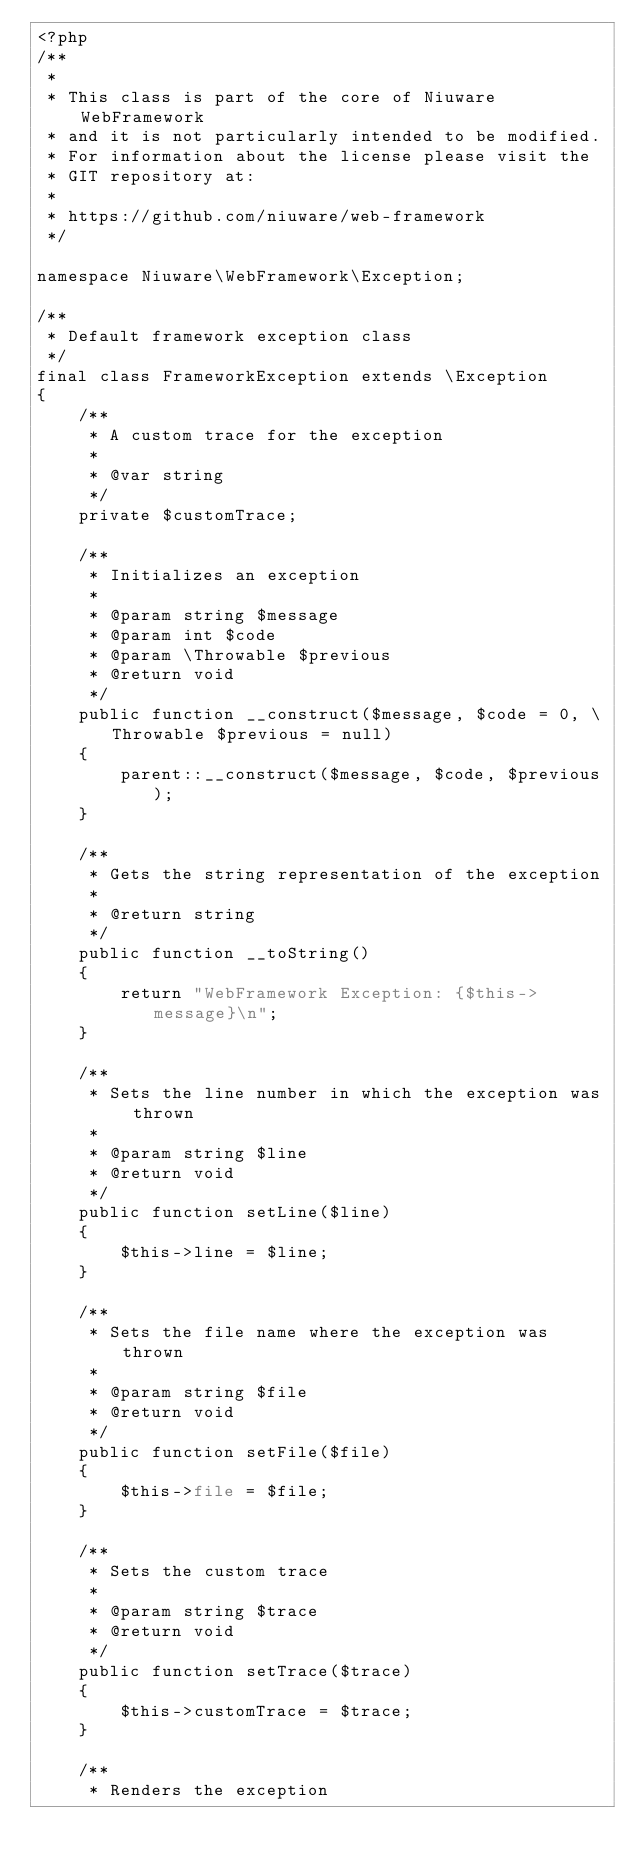<code> <loc_0><loc_0><loc_500><loc_500><_PHP_><?php 
/**
 * 
 * This class is part of the core of Niuware WebFramework 
 * and it is not particularly intended to be modified.
 * For information about the license please visit the 
 * GIT repository at:
 * 
 * https://github.com/niuware/web-framework
 */

namespace Niuware\WebFramework\Exception;

/**
 * Default framework exception class
 */
final class FrameworkException extends \Exception
{
    /**
     * A custom trace for the exception
     * 
     * @var string
     */
    private $customTrace;
    
    /**
     * Initializes an exception
     * 
     * @param string $message
     * @param int $code
     * @param \Throwable $previous
     * @return void
     */
    public function __construct($message, $code = 0, \Throwable $previous = null)
    {
        parent::__construct($message, $code, $previous);
    }
    
    /**
     * Gets the string representation of the exception
     * 
     * @return string
     */
    public function __toString()
    {
        return "WebFramework Exception: {$this->message}\n";
    }
    
    /**
     * Sets the line number in which the exception was thrown
     * 
     * @param string $line
     * @return void
     */
    public function setLine($line)
    {
        $this->line = $line;
    }
    
    /**
     * Sets the file name where the exception was thrown
     * 
     * @param string $file
     * @return void
     */
    public function setFile($file)
    {
        $this->file = $file;
    }
    
    /**
     * Sets the custom trace
     * 
     * @param string $trace
     * @return void
     */
    public function setTrace($trace)
    {
        $this->customTrace = $trace;
    }
    
    /**
     * Renders the exception</code> 